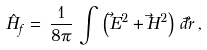<formula> <loc_0><loc_0><loc_500><loc_500>\hat { H } _ { f } = \, \frac { 1 } { 8 \pi } \, \int \, \left ( \vec { E } ^ { 2 } + \vec { H } ^ { 2 } \right ) \, d \vec { r } \, ,</formula> 